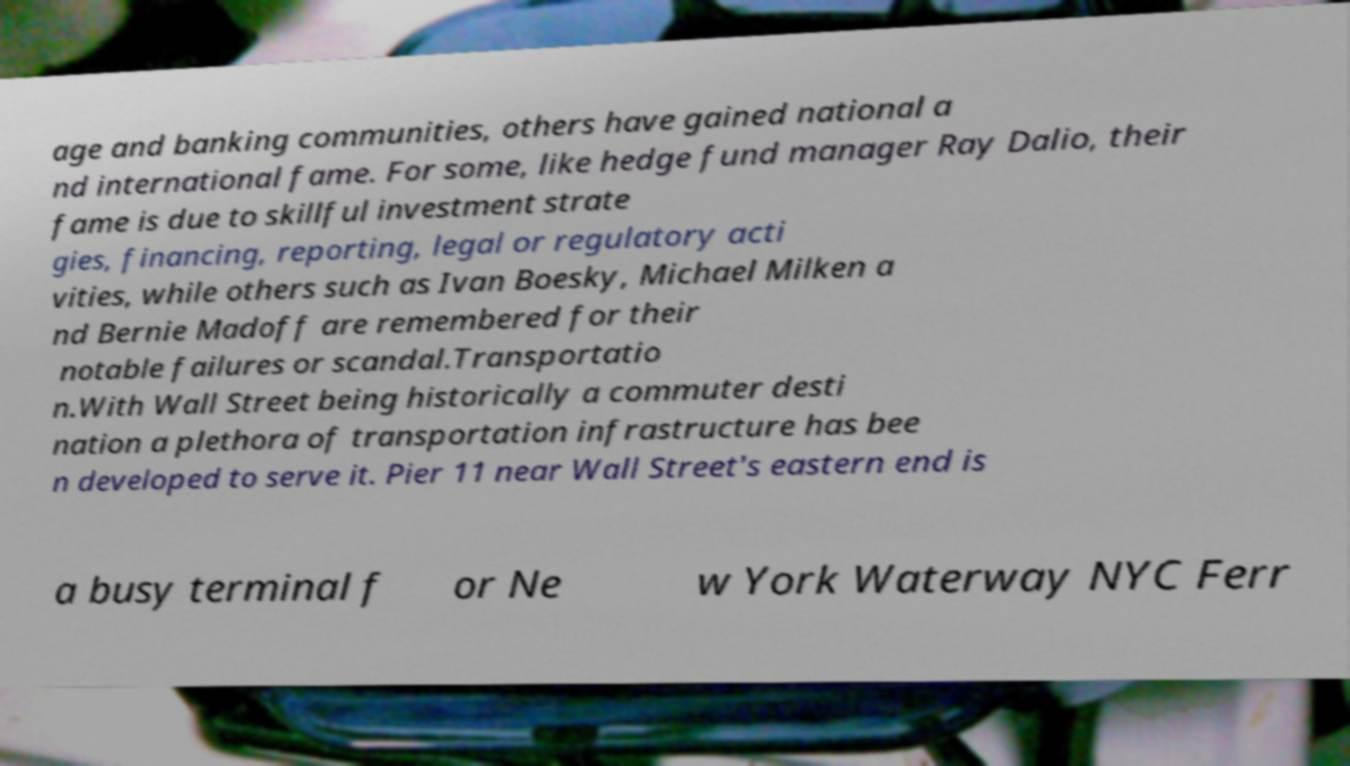Could you assist in decoding the text presented in this image and type it out clearly? age and banking communities, others have gained national a nd international fame. For some, like hedge fund manager Ray Dalio, their fame is due to skillful investment strate gies, financing, reporting, legal or regulatory acti vities, while others such as Ivan Boesky, Michael Milken a nd Bernie Madoff are remembered for their notable failures or scandal.Transportatio n.With Wall Street being historically a commuter desti nation a plethora of transportation infrastructure has bee n developed to serve it. Pier 11 near Wall Street's eastern end is a busy terminal f or Ne w York Waterway NYC Ferr 